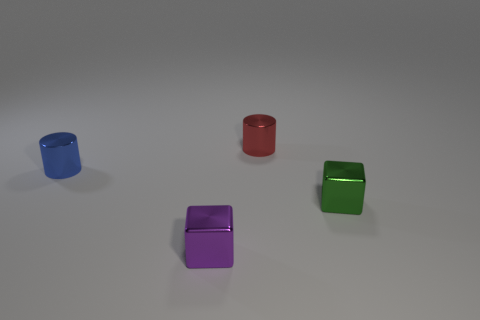What color is the other metal cube that is the same size as the green metallic block?
Keep it short and to the point. Purple. What number of tiny objects are on the left side of the red object?
Offer a very short reply. 2. Are there any small red objects that have the same material as the green thing?
Make the answer very short. Yes. The metal thing that is behind the small blue object is what color?
Offer a very short reply. Red. Are there an equal number of small red metallic things that are right of the red thing and blocks in front of the tiny green block?
Your response must be concise. No. There is a cylinder that is right of the small shiny cylinder on the left side of the red metal cylinder; what is its material?
Provide a succinct answer. Metal. What number of things are either purple objects or tiny blocks that are to the right of the purple metal thing?
Your answer should be compact. 2. What is the size of the blue cylinder that is the same material as the small green cube?
Your answer should be very brief. Small. Are there more tiny purple cubes that are behind the blue object than red shiny blocks?
Your response must be concise. No. There is a object that is left of the small red thing and on the right side of the blue cylinder; what size is it?
Offer a very short reply. Small. 